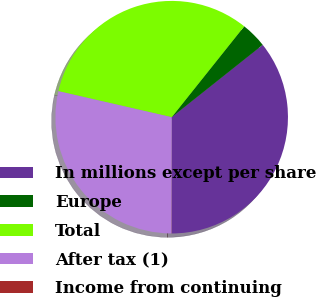<chart> <loc_0><loc_0><loc_500><loc_500><pie_chart><fcel>In millions except per share<fcel>Europe<fcel>Total<fcel>After tax (1)<fcel>Income from continuing<nl><fcel>35.7%<fcel>3.59%<fcel>32.13%<fcel>28.56%<fcel>0.02%<nl></chart> 